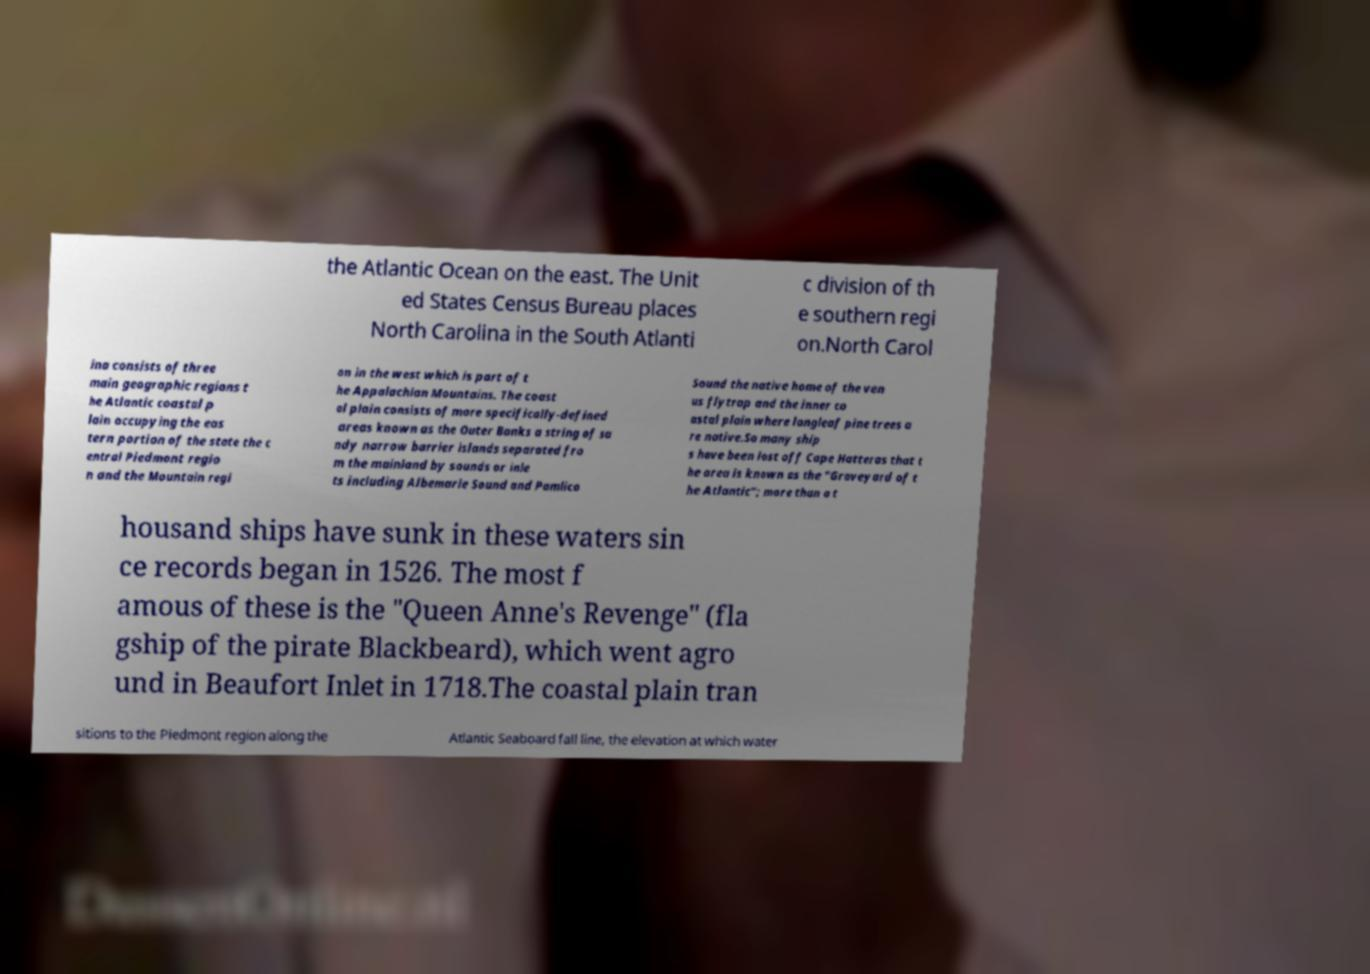Please read and relay the text visible in this image. What does it say? the Atlantic Ocean on the east. The Unit ed States Census Bureau places North Carolina in the South Atlanti c division of th e southern regi on.North Carol ina consists of three main geographic regions t he Atlantic coastal p lain occupying the eas tern portion of the state the c entral Piedmont regio n and the Mountain regi on in the west which is part of t he Appalachian Mountains. The coast al plain consists of more specifically-defined areas known as the Outer Banks a string of sa ndy narrow barrier islands separated fro m the mainland by sounds or inle ts including Albemarle Sound and Pamlico Sound the native home of the ven us flytrap and the inner co astal plain where longleaf pine trees a re native.So many ship s have been lost off Cape Hatteras that t he area is known as the "Graveyard of t he Atlantic"; more than a t housand ships have sunk in these waters sin ce records began in 1526. The most f amous of these is the "Queen Anne's Revenge" (fla gship of the pirate Blackbeard), which went agro und in Beaufort Inlet in 1718.The coastal plain tran sitions to the Piedmont region along the Atlantic Seaboard fall line, the elevation at which water 